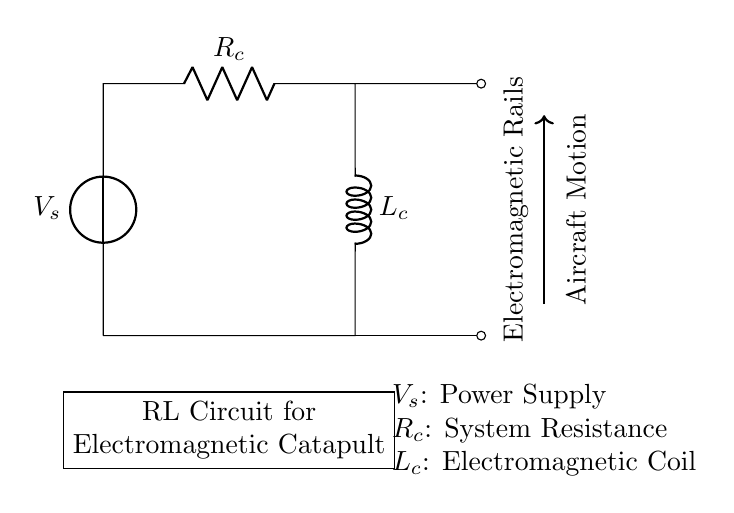What is the type of voltage source in this circuit? The circuit diagram shows a voltage source represented by a symbol, indicating that it provides electrical energy to the circuit.
Answer: Voltage source What is the resistance value denoted in the circuit? The circuit includes a resistor labeled as R_c, indicating it is the system resistance in this RL circuit. The value would be identified from a detailed specification but is not provided in the diagram itself.
Answer: R_c What is the purpose of the inductor in this circuit? The inductor labeled L_c is used to store energy temporarily in a magnetic field when current passes through it, which is crucial for the operation of the electromagnetic catapult.
Answer: Energy storage What do the labels "Electromagnetic Rails" signify? The label indicates the section of the circuit where electromagnetic forces are applied to launch the aircraft, showcasing the functional application of this RL circuit.
Answer: Electromagnetic force application How does the current behave in an RL circuit during power-on? In an RL circuit, when power is applied, the current gradually increases due to the inductor opposing rapid changes in current, leading to an exponential rise until it reaches a steady state.
Answer: Gradually increases What is the role of the electromagnetic coil in this system? The electromagnetic coil, labeled L_c, generates a magnetic field when current flows, which interacts with the electromagnetic rails to propel the aircraft forward.
Answer: Generate magnetic field 